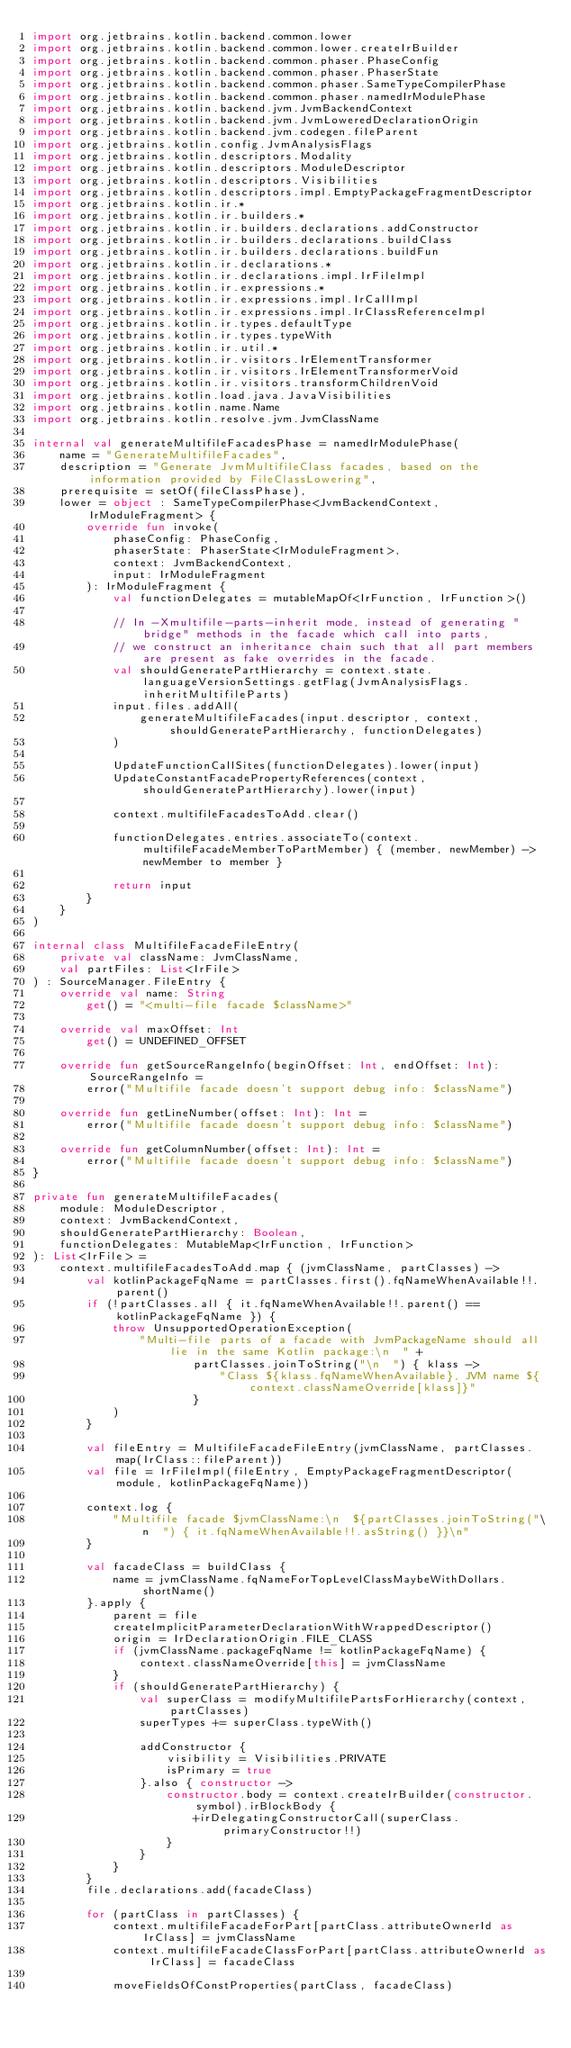Convert code to text. <code><loc_0><loc_0><loc_500><loc_500><_Kotlin_>import org.jetbrains.kotlin.backend.common.lower
import org.jetbrains.kotlin.backend.common.lower.createIrBuilder
import org.jetbrains.kotlin.backend.common.phaser.PhaseConfig
import org.jetbrains.kotlin.backend.common.phaser.PhaserState
import org.jetbrains.kotlin.backend.common.phaser.SameTypeCompilerPhase
import org.jetbrains.kotlin.backend.common.phaser.namedIrModulePhase
import org.jetbrains.kotlin.backend.jvm.JvmBackendContext
import org.jetbrains.kotlin.backend.jvm.JvmLoweredDeclarationOrigin
import org.jetbrains.kotlin.backend.jvm.codegen.fileParent
import org.jetbrains.kotlin.config.JvmAnalysisFlags
import org.jetbrains.kotlin.descriptors.Modality
import org.jetbrains.kotlin.descriptors.ModuleDescriptor
import org.jetbrains.kotlin.descriptors.Visibilities
import org.jetbrains.kotlin.descriptors.impl.EmptyPackageFragmentDescriptor
import org.jetbrains.kotlin.ir.*
import org.jetbrains.kotlin.ir.builders.*
import org.jetbrains.kotlin.ir.builders.declarations.addConstructor
import org.jetbrains.kotlin.ir.builders.declarations.buildClass
import org.jetbrains.kotlin.ir.builders.declarations.buildFun
import org.jetbrains.kotlin.ir.declarations.*
import org.jetbrains.kotlin.ir.declarations.impl.IrFileImpl
import org.jetbrains.kotlin.ir.expressions.*
import org.jetbrains.kotlin.ir.expressions.impl.IrCallImpl
import org.jetbrains.kotlin.ir.expressions.impl.IrClassReferenceImpl
import org.jetbrains.kotlin.ir.types.defaultType
import org.jetbrains.kotlin.ir.types.typeWith
import org.jetbrains.kotlin.ir.util.*
import org.jetbrains.kotlin.ir.visitors.IrElementTransformer
import org.jetbrains.kotlin.ir.visitors.IrElementTransformerVoid
import org.jetbrains.kotlin.ir.visitors.transformChildrenVoid
import org.jetbrains.kotlin.load.java.JavaVisibilities
import org.jetbrains.kotlin.name.Name
import org.jetbrains.kotlin.resolve.jvm.JvmClassName

internal val generateMultifileFacadesPhase = namedIrModulePhase(
    name = "GenerateMultifileFacades",
    description = "Generate JvmMultifileClass facades, based on the information provided by FileClassLowering",
    prerequisite = setOf(fileClassPhase),
    lower = object : SameTypeCompilerPhase<JvmBackendContext, IrModuleFragment> {
        override fun invoke(
            phaseConfig: PhaseConfig,
            phaserState: PhaserState<IrModuleFragment>,
            context: JvmBackendContext,
            input: IrModuleFragment
        ): IrModuleFragment {
            val functionDelegates = mutableMapOf<IrFunction, IrFunction>()

            // In -Xmultifile-parts-inherit mode, instead of generating "bridge" methods in the facade which call into parts,
            // we construct an inheritance chain such that all part members are present as fake overrides in the facade.
            val shouldGeneratePartHierarchy = context.state.languageVersionSettings.getFlag(JvmAnalysisFlags.inheritMultifileParts)
            input.files.addAll(
                generateMultifileFacades(input.descriptor, context, shouldGeneratePartHierarchy, functionDelegates)
            )

            UpdateFunctionCallSites(functionDelegates).lower(input)
            UpdateConstantFacadePropertyReferences(context, shouldGeneratePartHierarchy).lower(input)

            context.multifileFacadesToAdd.clear()

            functionDelegates.entries.associateTo(context.multifileFacadeMemberToPartMember) { (member, newMember) -> newMember to member }

            return input
        }
    }
)

internal class MultifileFacadeFileEntry(
    private val className: JvmClassName,
    val partFiles: List<IrFile>
) : SourceManager.FileEntry {
    override val name: String
        get() = "<multi-file facade $className>"

    override val maxOffset: Int
        get() = UNDEFINED_OFFSET

    override fun getSourceRangeInfo(beginOffset: Int, endOffset: Int): SourceRangeInfo =
        error("Multifile facade doesn't support debug info: $className")

    override fun getLineNumber(offset: Int): Int =
        error("Multifile facade doesn't support debug info: $className")

    override fun getColumnNumber(offset: Int): Int =
        error("Multifile facade doesn't support debug info: $className")
}

private fun generateMultifileFacades(
    module: ModuleDescriptor,
    context: JvmBackendContext,
    shouldGeneratePartHierarchy: Boolean,
    functionDelegates: MutableMap<IrFunction, IrFunction>
): List<IrFile> =
    context.multifileFacadesToAdd.map { (jvmClassName, partClasses) ->
        val kotlinPackageFqName = partClasses.first().fqNameWhenAvailable!!.parent()
        if (!partClasses.all { it.fqNameWhenAvailable!!.parent() == kotlinPackageFqName }) {
            throw UnsupportedOperationException(
                "Multi-file parts of a facade with JvmPackageName should all lie in the same Kotlin package:\n  " +
                        partClasses.joinToString("\n  ") { klass ->
                            "Class ${klass.fqNameWhenAvailable}, JVM name ${context.classNameOverride[klass]}"
                        }
            )
        }

        val fileEntry = MultifileFacadeFileEntry(jvmClassName, partClasses.map(IrClass::fileParent))
        val file = IrFileImpl(fileEntry, EmptyPackageFragmentDescriptor(module, kotlinPackageFqName))

        context.log {
            "Multifile facade $jvmClassName:\n  ${partClasses.joinToString("\n  ") { it.fqNameWhenAvailable!!.asString() }}\n"
        }

        val facadeClass = buildClass {
            name = jvmClassName.fqNameForTopLevelClassMaybeWithDollars.shortName()
        }.apply {
            parent = file
            createImplicitParameterDeclarationWithWrappedDescriptor()
            origin = IrDeclarationOrigin.FILE_CLASS
            if (jvmClassName.packageFqName != kotlinPackageFqName) {
                context.classNameOverride[this] = jvmClassName
            }
            if (shouldGeneratePartHierarchy) {
                val superClass = modifyMultifilePartsForHierarchy(context, partClasses)
                superTypes += superClass.typeWith()

                addConstructor {
                    visibility = Visibilities.PRIVATE
                    isPrimary = true
                }.also { constructor ->
                    constructor.body = context.createIrBuilder(constructor.symbol).irBlockBody {
                        +irDelegatingConstructorCall(superClass.primaryConstructor!!)
                    }
                }
            }
        }
        file.declarations.add(facadeClass)

        for (partClass in partClasses) {
            context.multifileFacadeForPart[partClass.attributeOwnerId as IrClass] = jvmClassName
            context.multifileFacadeClassForPart[partClass.attributeOwnerId as IrClass] = facadeClass

            moveFieldsOfConstProperties(partClass, facadeClass)
</code> 